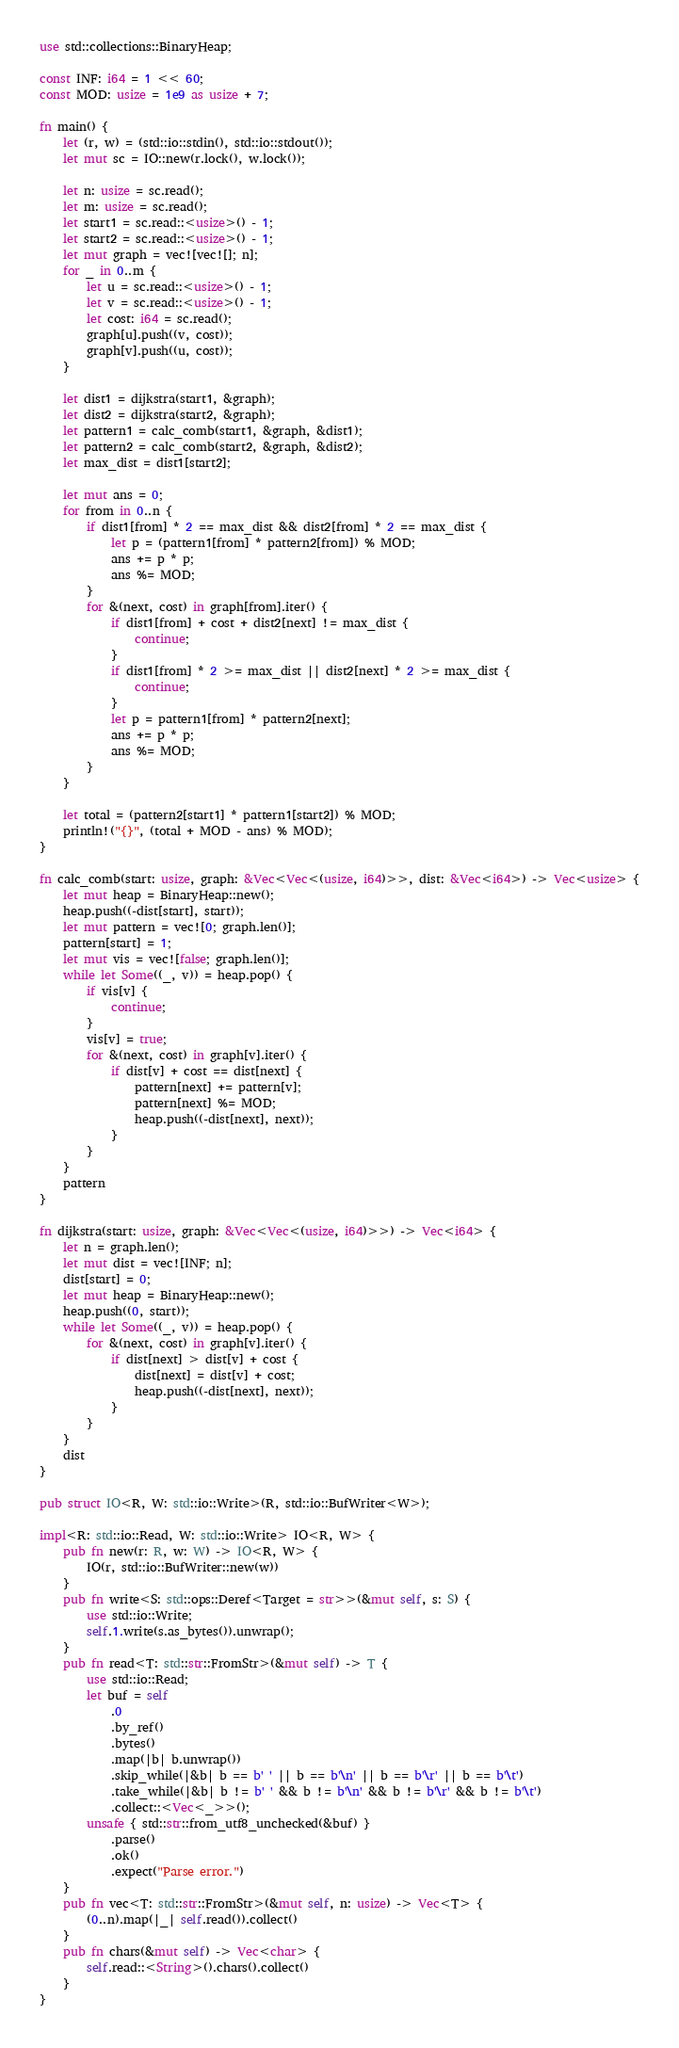<code> <loc_0><loc_0><loc_500><loc_500><_Rust_>use std::collections::BinaryHeap;

const INF: i64 = 1 << 60;
const MOD: usize = 1e9 as usize + 7;

fn main() {
    let (r, w) = (std::io::stdin(), std::io::stdout());
    let mut sc = IO::new(r.lock(), w.lock());

    let n: usize = sc.read();
    let m: usize = sc.read();
    let start1 = sc.read::<usize>() - 1;
    let start2 = sc.read::<usize>() - 1;
    let mut graph = vec![vec![]; n];
    for _ in 0..m {
        let u = sc.read::<usize>() - 1;
        let v = sc.read::<usize>() - 1;
        let cost: i64 = sc.read();
        graph[u].push((v, cost));
        graph[v].push((u, cost));
    }

    let dist1 = dijkstra(start1, &graph);
    let dist2 = dijkstra(start2, &graph);
    let pattern1 = calc_comb(start1, &graph, &dist1);
    let pattern2 = calc_comb(start2, &graph, &dist2);
    let max_dist = dist1[start2];

    let mut ans = 0;
    for from in 0..n {
        if dist1[from] * 2 == max_dist && dist2[from] * 2 == max_dist {
            let p = (pattern1[from] * pattern2[from]) % MOD;
            ans += p * p;
            ans %= MOD;
        }
        for &(next, cost) in graph[from].iter() {
            if dist1[from] + cost + dist2[next] != max_dist {
                continue;
            }
            if dist1[from] * 2 >= max_dist || dist2[next] * 2 >= max_dist {
                continue;
            }
            let p = pattern1[from] * pattern2[next];
            ans += p * p;
            ans %= MOD;
        }
    }

    let total = (pattern2[start1] * pattern1[start2]) % MOD;
    println!("{}", (total + MOD - ans) % MOD);
}

fn calc_comb(start: usize, graph: &Vec<Vec<(usize, i64)>>, dist: &Vec<i64>) -> Vec<usize> {
    let mut heap = BinaryHeap::new();
    heap.push((-dist[start], start));
    let mut pattern = vec![0; graph.len()];
    pattern[start] = 1;
    let mut vis = vec![false; graph.len()];
    while let Some((_, v)) = heap.pop() {
        if vis[v] {
            continue;
        }
        vis[v] = true;
        for &(next, cost) in graph[v].iter() {
            if dist[v] + cost == dist[next] {
                pattern[next] += pattern[v];
                pattern[next] %= MOD;
                heap.push((-dist[next], next));
            }
        }
    }
    pattern
}

fn dijkstra(start: usize, graph: &Vec<Vec<(usize, i64)>>) -> Vec<i64> {
    let n = graph.len();
    let mut dist = vec![INF; n];
    dist[start] = 0;
    let mut heap = BinaryHeap::new();
    heap.push((0, start));
    while let Some((_, v)) = heap.pop() {
        for &(next, cost) in graph[v].iter() {
            if dist[next] > dist[v] + cost {
                dist[next] = dist[v] + cost;
                heap.push((-dist[next], next));
            }
        }
    }
    dist
}

pub struct IO<R, W: std::io::Write>(R, std::io::BufWriter<W>);

impl<R: std::io::Read, W: std::io::Write> IO<R, W> {
    pub fn new(r: R, w: W) -> IO<R, W> {
        IO(r, std::io::BufWriter::new(w))
    }
    pub fn write<S: std::ops::Deref<Target = str>>(&mut self, s: S) {
        use std::io::Write;
        self.1.write(s.as_bytes()).unwrap();
    }
    pub fn read<T: std::str::FromStr>(&mut self) -> T {
        use std::io::Read;
        let buf = self
            .0
            .by_ref()
            .bytes()
            .map(|b| b.unwrap())
            .skip_while(|&b| b == b' ' || b == b'\n' || b == b'\r' || b == b'\t')
            .take_while(|&b| b != b' ' && b != b'\n' && b != b'\r' && b != b'\t')
            .collect::<Vec<_>>();
        unsafe { std::str::from_utf8_unchecked(&buf) }
            .parse()
            .ok()
            .expect("Parse error.")
    }
    pub fn vec<T: std::str::FromStr>(&mut self, n: usize) -> Vec<T> {
        (0..n).map(|_| self.read()).collect()
    }
    pub fn chars(&mut self) -> Vec<char> {
        self.read::<String>().chars().collect()
    }
}
</code> 